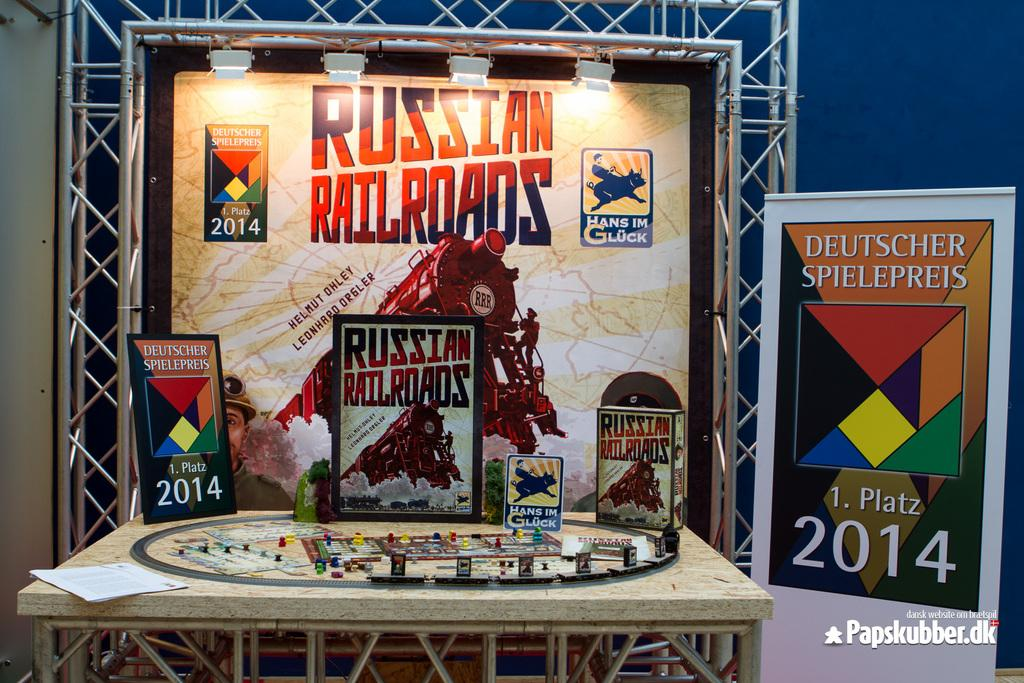<image>
Offer a succinct explanation of the picture presented. A display with cards and books and posters that say Russian Railroads. 